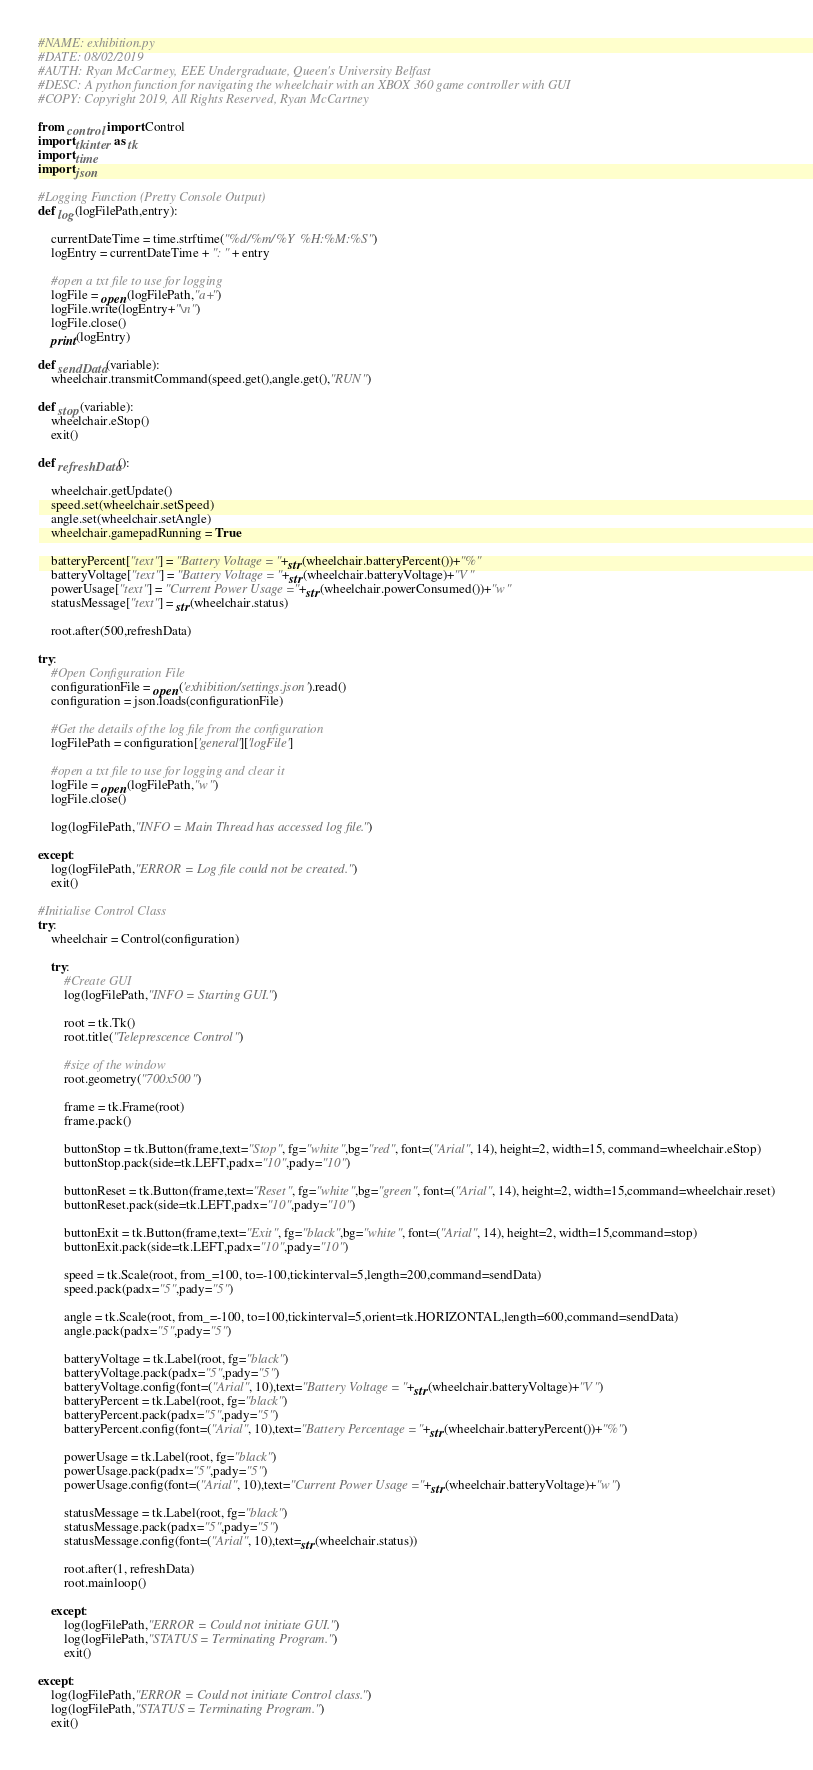<code> <loc_0><loc_0><loc_500><loc_500><_Python_>#NAME: exhibition.py
#DATE: 08/02/2019
#AUTH: Ryan McCartney, EEE Undergraduate, Queen's University Belfast
#DESC: A python function for navigating the wheelchair with an XBOX 360 game controller with GUI
#COPY: Copyright 2019, All Rights Reserved, Ryan McCartney

from control import Control
import tkinter as tk
import time
import json

#Logging Function (Pretty Console Output)
def log(logFilePath,entry):    

    currentDateTime = time.strftime("%d/%m/%Y %H:%M:%S")
    logEntry = currentDateTime + ": " + entry

    #open a txt file to use for logging
    logFile = open(logFilePath,"a+")
    logFile.write(logEntry+"\n")
    logFile.close()
    print(logEntry)

def sendData(variable):
    wheelchair.transmitCommand(speed.get(),angle.get(),"RUN")

def stop(variable):
    wheelchair.eStop()
    exit()

def refreshData():
    
    wheelchair.getUpdate()
    speed.set(wheelchair.setSpeed)
    angle.set(wheelchair.setAngle)
    wheelchair.gamepadRunning = True

    batteryPercent["text"] = "Battery Voltage = "+str(wheelchair.batteryPercent())+"%"
    batteryVoltage["text"] = "Battery Voltage = "+str(wheelchair.batteryVoltage)+"V"
    powerUsage["text"] = "Current Power Usage = "+str(wheelchair.powerConsumed())+"w"
    statusMessage["text"] = str(wheelchair.status)

    root.after(500,refreshData) 

try:
    #Open Configuration File
    configurationFile = open('exhibition/settings.json').read()
    configuration = json.loads(configurationFile)

    #Get the details of the log file from the configuration
    logFilePath = configuration['general']['logFile']

    #open a txt file to use for logging and clear it
    logFile = open(logFilePath,"w")
    logFile.close()

    log(logFilePath,"INFO = Main Thread has accessed log file.")

except:
    log(logFilePath,"ERROR = Log file could not be created.")
    exit()

#Initialise Control Class
try:
    wheelchair = Control(configuration)

    try:
        #Create GUI
        log(logFilePath,"INFO = Starting GUI.")

        root = tk.Tk()
        root.title("Teleprescence Control")

        #size of the window
        root.geometry("700x500")

        frame = tk.Frame(root)
        frame.pack()
        
        buttonStop = tk.Button(frame,text="Stop", fg="white",bg="red", font=("Arial", 14), height=2, width=15, command=wheelchair.eStop)
        buttonStop.pack(side=tk.LEFT,padx="10",pady="10")

        buttonReset = tk.Button(frame,text="Reset", fg="white",bg="green", font=("Arial", 14), height=2, width=15,command=wheelchair.reset)
        buttonReset.pack(side=tk.LEFT,padx="10",pady="10")

        buttonExit = tk.Button(frame,text="Exit", fg="black",bg="white", font=("Arial", 14), height=2, width=15,command=stop)
        buttonExit.pack(side=tk.LEFT,padx="10",pady="10")

        speed = tk.Scale(root, from_=100, to=-100,tickinterval=5,length=200,command=sendData)
        speed.pack(padx="5",pady="5")
        
        angle = tk.Scale(root, from_=-100, to=100,tickinterval=5,orient=tk.HORIZONTAL,length=600,command=sendData)
        angle.pack(padx="5",pady="5")

        batteryVoltage = tk.Label(root, fg="black")
        batteryVoltage.pack(padx="5",pady="5")
        batteryVoltage.config(font=("Arial", 10),text="Battery Voltage = "+str(wheelchair.batteryVoltage)+"V")
        batteryPercent = tk.Label(root, fg="black")
        batteryPercent.pack(padx="5",pady="5")
        batteryPercent.config(font=("Arial", 10),text="Battery Percentage = "+str(wheelchair.batteryPercent())+"%")
        
        powerUsage = tk.Label(root, fg="black")
        powerUsage.pack(padx="5",pady="5")
        powerUsage.config(font=("Arial", 10),text="Current Power Usage = "+str(wheelchair.batteryVoltage)+"w")

        statusMessage = tk.Label(root, fg="black")
        statusMessage.pack(padx="5",pady="5")
        statusMessage.config(font=("Arial", 10),text=str(wheelchair.status))

        root.after(1, refreshData)
        root.mainloop()

    except:
        log(logFilePath,"ERROR = Could not initiate GUI.")
        log(logFilePath,"STATUS = Terminating Program.")
        exit()

except:
    log(logFilePath,"ERROR = Could not initiate Control class.")
    log(logFilePath,"STATUS = Terminating Program.")
    exit()</code> 